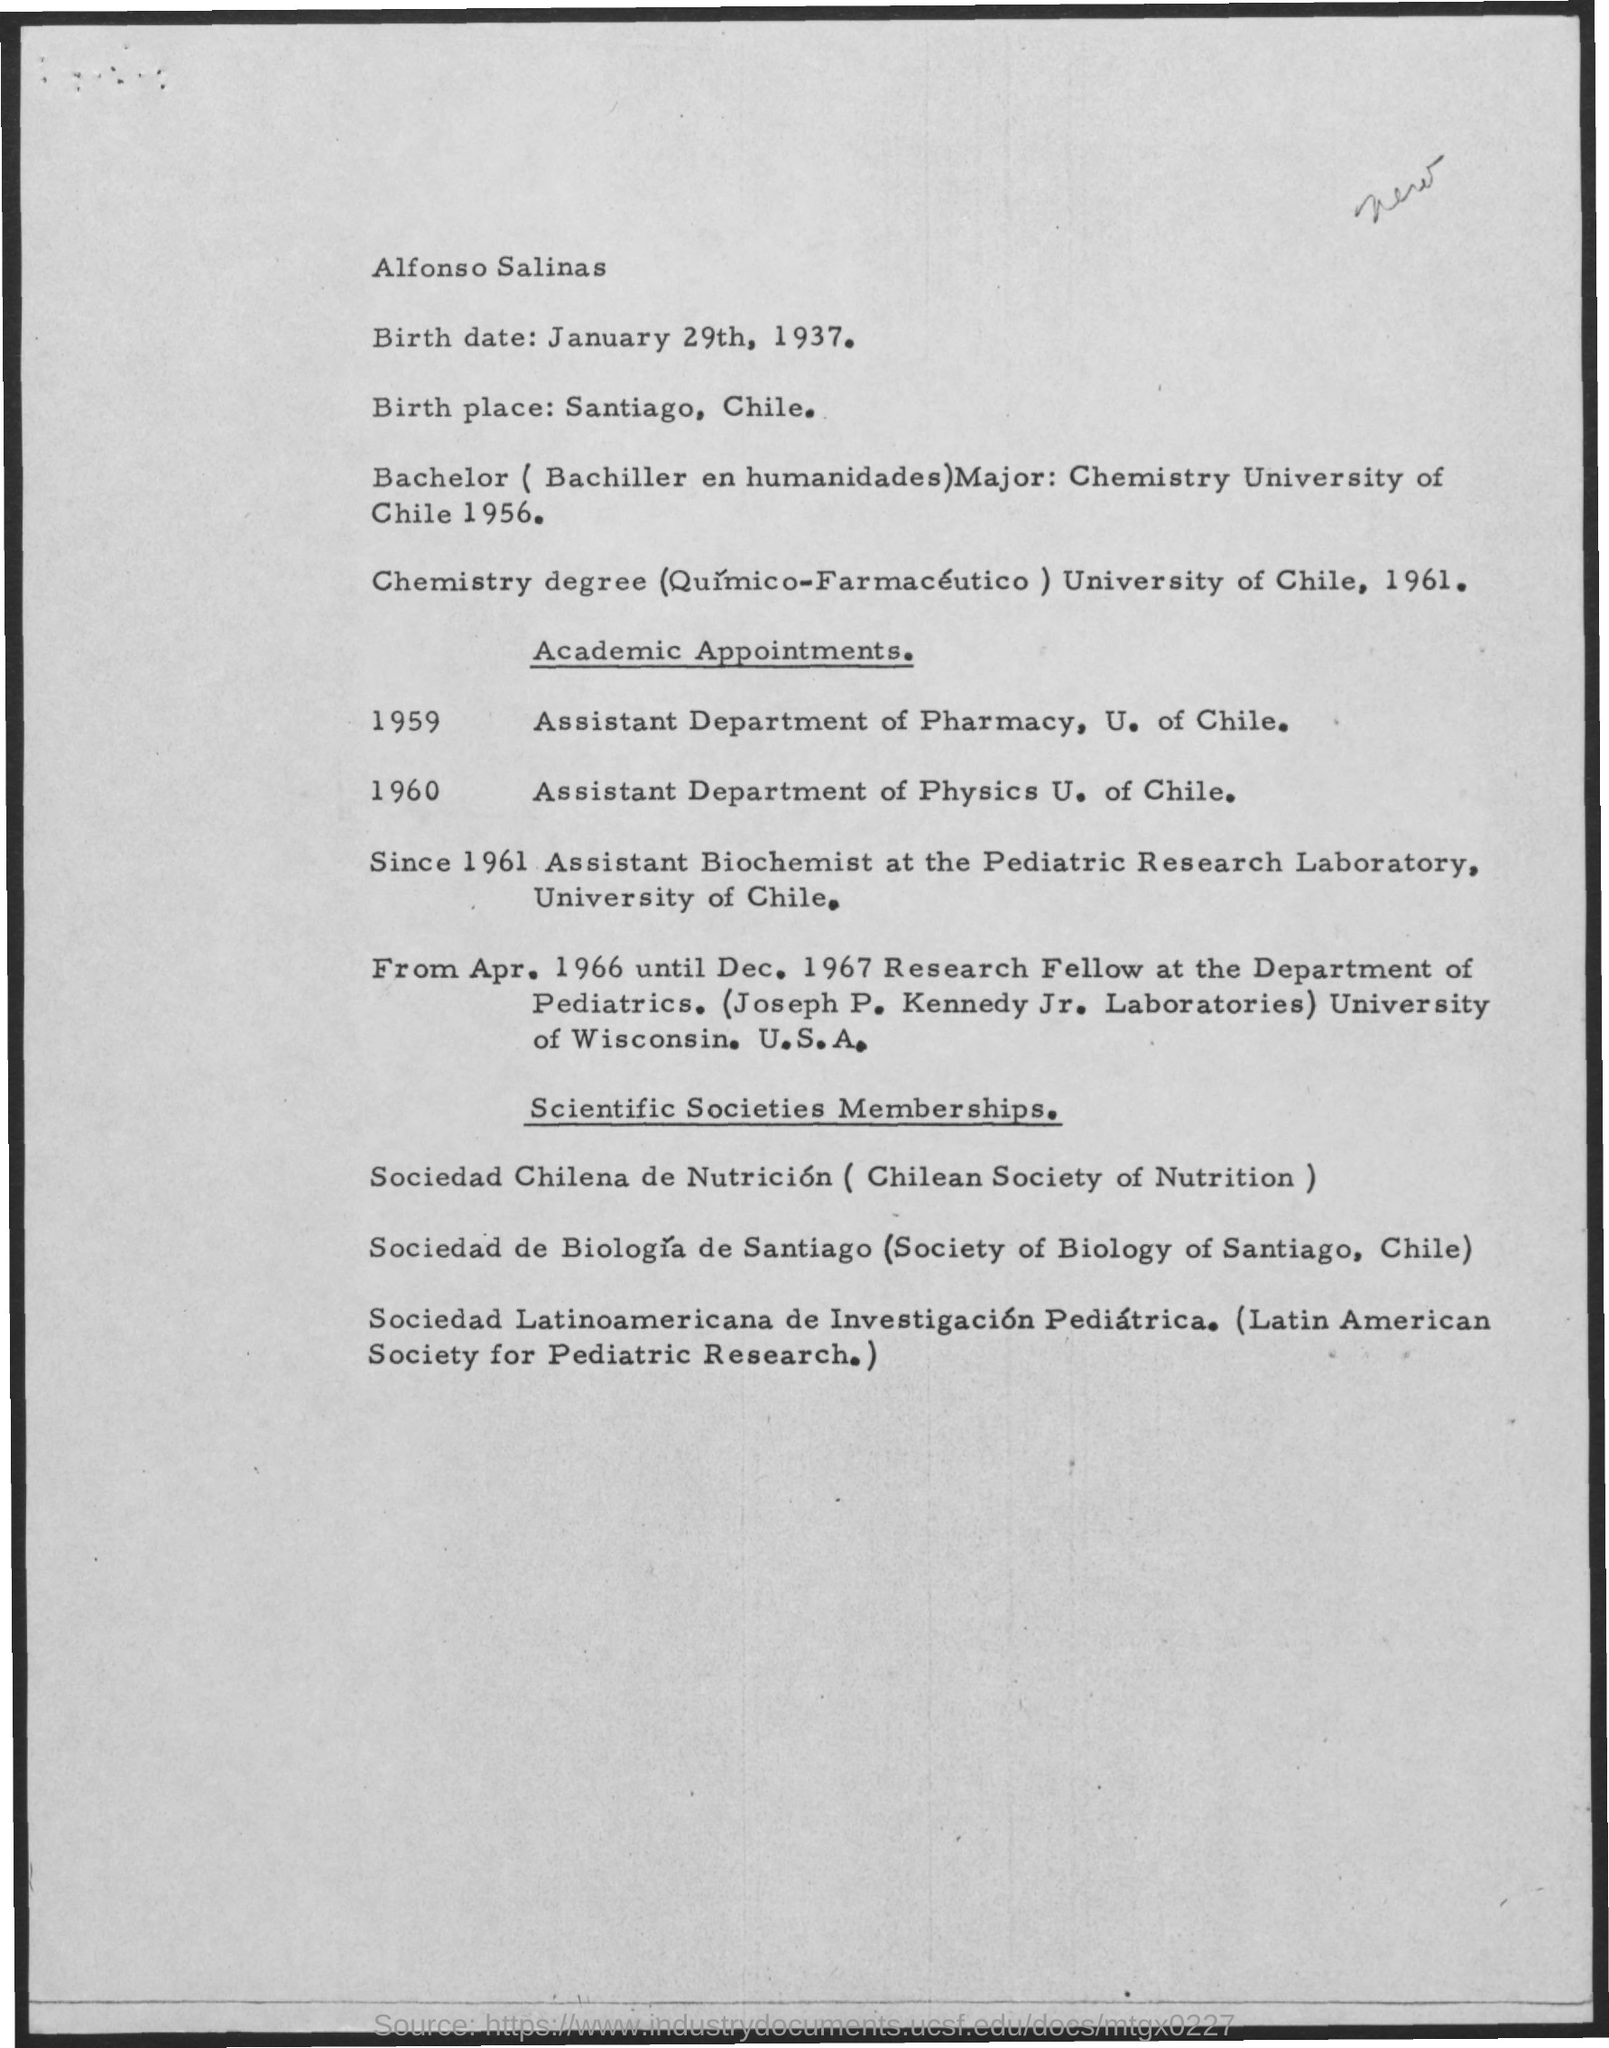Birth date of Alfonso Salinas?
Provide a short and direct response. January 29th, 1937. Where is birth place of Alfonso Salinas?
Your response must be concise. Santiago, Chile. 